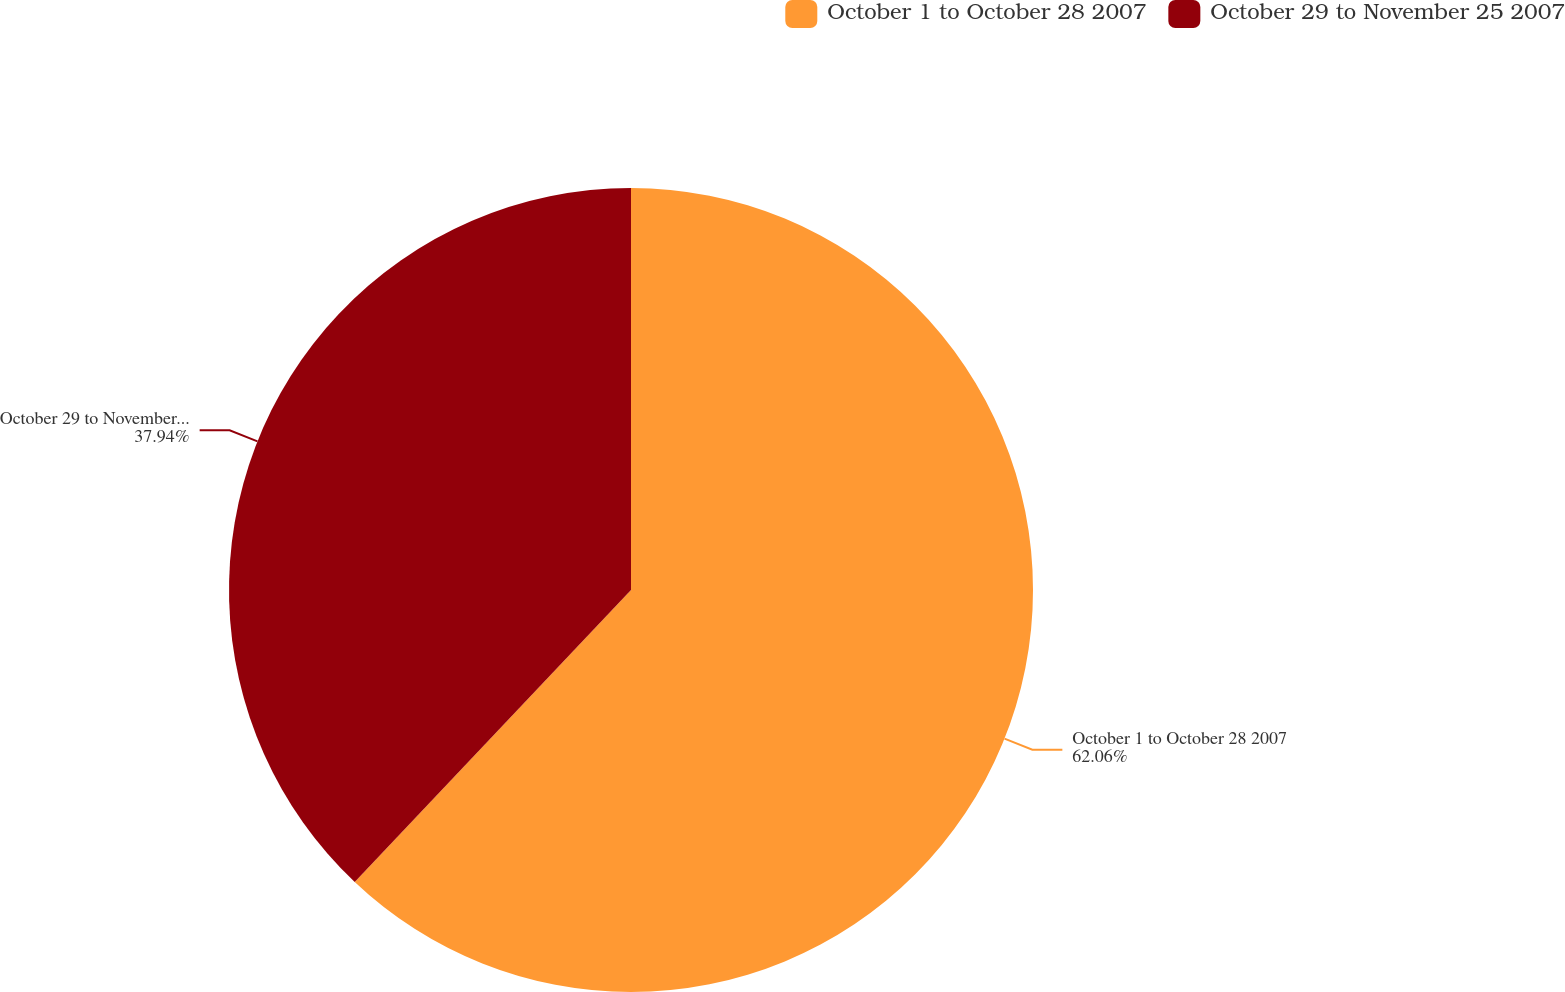<chart> <loc_0><loc_0><loc_500><loc_500><pie_chart><fcel>October 1 to October 28 2007<fcel>October 29 to November 25 2007<nl><fcel>62.06%<fcel>37.94%<nl></chart> 